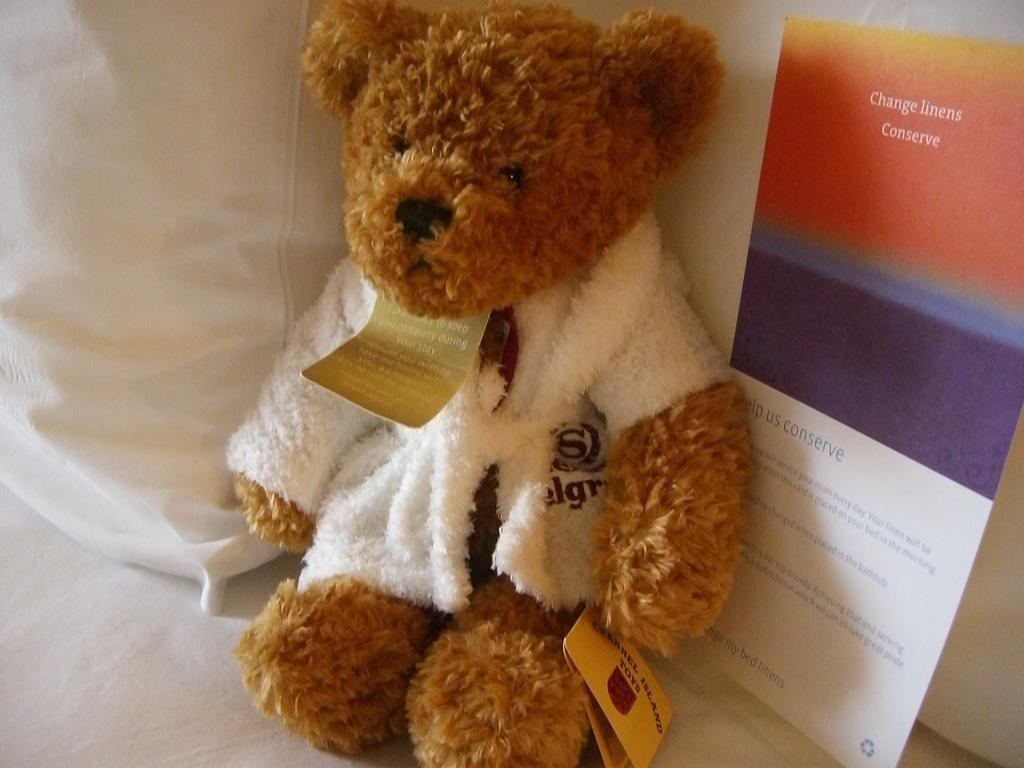What is the main subject of the picture? The main subject of the picture is a teddy. What color is the teddy? The teddy is brown in color. What is the teddy wearing? The teddy is wearing a white jacket. Where is the teddy sitting? The teddy is sitting on a white cloth. What is located beside the teddy? There is a card beside the teddy. What type of honey is being poured on the teddy in the image? There is no honey present in the image; it features a teddy sitting on a white cloth with a card beside it. What channel is the teddy watching on the television in the image? There is no television present in the image, so it is not possible to determine what channel the teddy might be watching. 